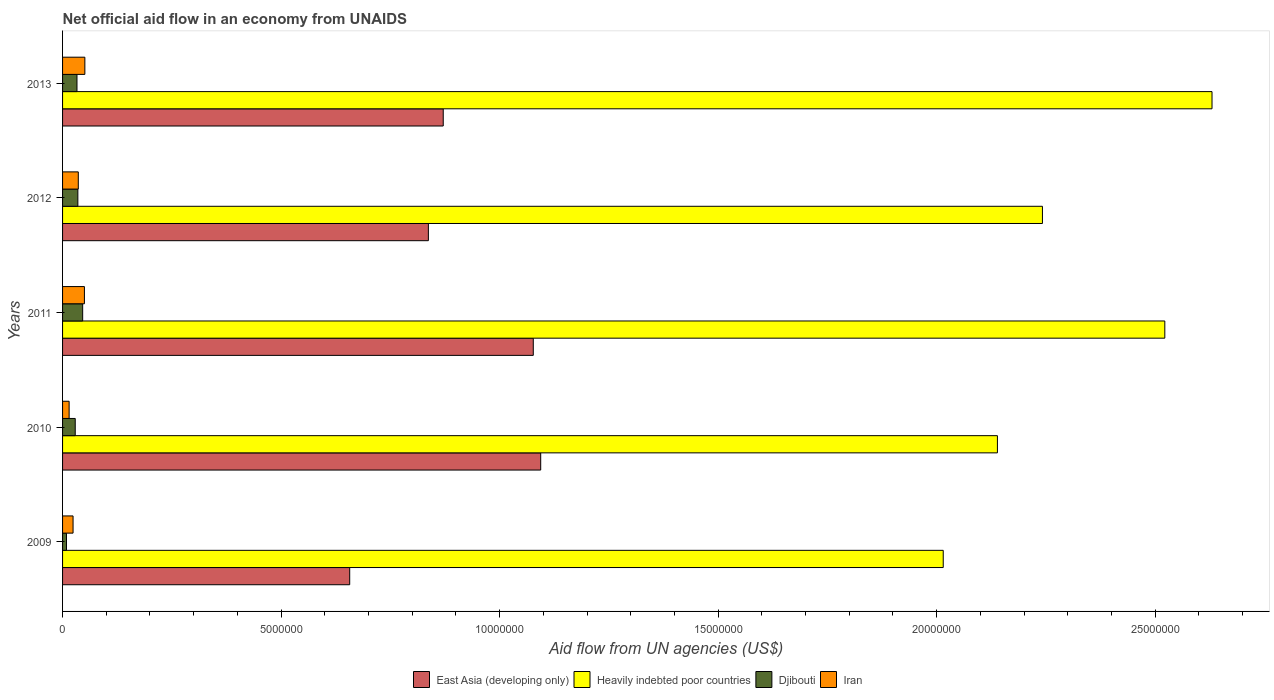How many different coloured bars are there?
Your answer should be compact. 4. Are the number of bars per tick equal to the number of legend labels?
Your response must be concise. Yes. Are the number of bars on each tick of the Y-axis equal?
Give a very brief answer. Yes. How many bars are there on the 3rd tick from the bottom?
Your answer should be very brief. 4. What is the label of the 5th group of bars from the top?
Make the answer very short. 2009. What is the net official aid flow in Heavily indebted poor countries in 2013?
Ensure brevity in your answer.  2.63e+07. Across all years, what is the maximum net official aid flow in Iran?
Your response must be concise. 5.10e+05. Across all years, what is the minimum net official aid flow in Djibouti?
Provide a short and direct response. 9.00e+04. In which year was the net official aid flow in Djibouti maximum?
Keep it short and to the point. 2011. What is the total net official aid flow in East Asia (developing only) in the graph?
Give a very brief answer. 4.54e+07. What is the difference between the net official aid flow in Heavily indebted poor countries in 2010 and the net official aid flow in Djibouti in 2012?
Your answer should be very brief. 2.10e+07. What is the average net official aid flow in East Asia (developing only) per year?
Ensure brevity in your answer.  9.07e+06. In the year 2011, what is the difference between the net official aid flow in Djibouti and net official aid flow in Iran?
Keep it short and to the point. -4.00e+04. In how many years, is the net official aid flow in East Asia (developing only) greater than 13000000 US$?
Provide a succinct answer. 0. What is the ratio of the net official aid flow in East Asia (developing only) in 2012 to that in 2013?
Your response must be concise. 0.96. Is the net official aid flow in Heavily indebted poor countries in 2009 less than that in 2010?
Give a very brief answer. Yes. Is the difference between the net official aid flow in Djibouti in 2010 and 2013 greater than the difference between the net official aid flow in Iran in 2010 and 2013?
Provide a short and direct response. Yes. What is the difference between the highest and the second highest net official aid flow in Heavily indebted poor countries?
Offer a terse response. 1.08e+06. What does the 3rd bar from the top in 2010 represents?
Your answer should be compact. Heavily indebted poor countries. What does the 4th bar from the bottom in 2012 represents?
Your response must be concise. Iran. Is it the case that in every year, the sum of the net official aid flow in Heavily indebted poor countries and net official aid flow in East Asia (developing only) is greater than the net official aid flow in Djibouti?
Your answer should be compact. Yes. How many bars are there?
Give a very brief answer. 20. What is the difference between two consecutive major ticks on the X-axis?
Ensure brevity in your answer.  5.00e+06. How many legend labels are there?
Your answer should be compact. 4. What is the title of the graph?
Provide a short and direct response. Net official aid flow in an economy from UNAIDS. What is the label or title of the X-axis?
Keep it short and to the point. Aid flow from UN agencies (US$). What is the Aid flow from UN agencies (US$) of East Asia (developing only) in 2009?
Ensure brevity in your answer.  6.57e+06. What is the Aid flow from UN agencies (US$) in Heavily indebted poor countries in 2009?
Ensure brevity in your answer.  2.02e+07. What is the Aid flow from UN agencies (US$) in Djibouti in 2009?
Ensure brevity in your answer.  9.00e+04. What is the Aid flow from UN agencies (US$) of East Asia (developing only) in 2010?
Your answer should be compact. 1.09e+07. What is the Aid flow from UN agencies (US$) in Heavily indebted poor countries in 2010?
Your response must be concise. 2.14e+07. What is the Aid flow from UN agencies (US$) in East Asia (developing only) in 2011?
Your answer should be compact. 1.08e+07. What is the Aid flow from UN agencies (US$) of Heavily indebted poor countries in 2011?
Provide a succinct answer. 2.52e+07. What is the Aid flow from UN agencies (US$) of Iran in 2011?
Ensure brevity in your answer.  5.00e+05. What is the Aid flow from UN agencies (US$) of East Asia (developing only) in 2012?
Give a very brief answer. 8.37e+06. What is the Aid flow from UN agencies (US$) of Heavily indebted poor countries in 2012?
Ensure brevity in your answer.  2.24e+07. What is the Aid flow from UN agencies (US$) in Djibouti in 2012?
Provide a succinct answer. 3.50e+05. What is the Aid flow from UN agencies (US$) in East Asia (developing only) in 2013?
Keep it short and to the point. 8.71e+06. What is the Aid flow from UN agencies (US$) in Heavily indebted poor countries in 2013?
Your answer should be very brief. 2.63e+07. What is the Aid flow from UN agencies (US$) of Djibouti in 2013?
Give a very brief answer. 3.30e+05. What is the Aid flow from UN agencies (US$) of Iran in 2013?
Offer a terse response. 5.10e+05. Across all years, what is the maximum Aid flow from UN agencies (US$) in East Asia (developing only)?
Offer a terse response. 1.09e+07. Across all years, what is the maximum Aid flow from UN agencies (US$) of Heavily indebted poor countries?
Give a very brief answer. 2.63e+07. Across all years, what is the maximum Aid flow from UN agencies (US$) of Iran?
Make the answer very short. 5.10e+05. Across all years, what is the minimum Aid flow from UN agencies (US$) in East Asia (developing only)?
Offer a terse response. 6.57e+06. Across all years, what is the minimum Aid flow from UN agencies (US$) in Heavily indebted poor countries?
Offer a very short reply. 2.02e+07. Across all years, what is the minimum Aid flow from UN agencies (US$) of Iran?
Provide a succinct answer. 1.50e+05. What is the total Aid flow from UN agencies (US$) in East Asia (developing only) in the graph?
Ensure brevity in your answer.  4.54e+07. What is the total Aid flow from UN agencies (US$) of Heavily indebted poor countries in the graph?
Offer a terse response. 1.15e+08. What is the total Aid flow from UN agencies (US$) of Djibouti in the graph?
Your answer should be compact. 1.52e+06. What is the total Aid flow from UN agencies (US$) in Iran in the graph?
Offer a terse response. 1.76e+06. What is the difference between the Aid flow from UN agencies (US$) in East Asia (developing only) in 2009 and that in 2010?
Your response must be concise. -4.37e+06. What is the difference between the Aid flow from UN agencies (US$) of Heavily indebted poor countries in 2009 and that in 2010?
Give a very brief answer. -1.24e+06. What is the difference between the Aid flow from UN agencies (US$) in Iran in 2009 and that in 2010?
Make the answer very short. 9.00e+04. What is the difference between the Aid flow from UN agencies (US$) of East Asia (developing only) in 2009 and that in 2011?
Offer a very short reply. -4.20e+06. What is the difference between the Aid flow from UN agencies (US$) in Heavily indebted poor countries in 2009 and that in 2011?
Your response must be concise. -5.07e+06. What is the difference between the Aid flow from UN agencies (US$) in Djibouti in 2009 and that in 2011?
Offer a terse response. -3.70e+05. What is the difference between the Aid flow from UN agencies (US$) in East Asia (developing only) in 2009 and that in 2012?
Provide a succinct answer. -1.80e+06. What is the difference between the Aid flow from UN agencies (US$) of Heavily indebted poor countries in 2009 and that in 2012?
Provide a short and direct response. -2.27e+06. What is the difference between the Aid flow from UN agencies (US$) in East Asia (developing only) in 2009 and that in 2013?
Your response must be concise. -2.14e+06. What is the difference between the Aid flow from UN agencies (US$) of Heavily indebted poor countries in 2009 and that in 2013?
Offer a terse response. -6.15e+06. What is the difference between the Aid flow from UN agencies (US$) of Djibouti in 2009 and that in 2013?
Offer a very short reply. -2.40e+05. What is the difference between the Aid flow from UN agencies (US$) of Heavily indebted poor countries in 2010 and that in 2011?
Keep it short and to the point. -3.83e+06. What is the difference between the Aid flow from UN agencies (US$) of Iran in 2010 and that in 2011?
Give a very brief answer. -3.50e+05. What is the difference between the Aid flow from UN agencies (US$) in East Asia (developing only) in 2010 and that in 2012?
Keep it short and to the point. 2.57e+06. What is the difference between the Aid flow from UN agencies (US$) in Heavily indebted poor countries in 2010 and that in 2012?
Provide a short and direct response. -1.03e+06. What is the difference between the Aid flow from UN agencies (US$) in Iran in 2010 and that in 2012?
Your answer should be very brief. -2.10e+05. What is the difference between the Aid flow from UN agencies (US$) of East Asia (developing only) in 2010 and that in 2013?
Offer a terse response. 2.23e+06. What is the difference between the Aid flow from UN agencies (US$) in Heavily indebted poor countries in 2010 and that in 2013?
Give a very brief answer. -4.91e+06. What is the difference between the Aid flow from UN agencies (US$) in Iran in 2010 and that in 2013?
Offer a very short reply. -3.60e+05. What is the difference between the Aid flow from UN agencies (US$) in East Asia (developing only) in 2011 and that in 2012?
Your answer should be compact. 2.40e+06. What is the difference between the Aid flow from UN agencies (US$) of Heavily indebted poor countries in 2011 and that in 2012?
Provide a short and direct response. 2.80e+06. What is the difference between the Aid flow from UN agencies (US$) of Djibouti in 2011 and that in 2012?
Give a very brief answer. 1.10e+05. What is the difference between the Aid flow from UN agencies (US$) of Iran in 2011 and that in 2012?
Ensure brevity in your answer.  1.40e+05. What is the difference between the Aid flow from UN agencies (US$) of East Asia (developing only) in 2011 and that in 2013?
Your response must be concise. 2.06e+06. What is the difference between the Aid flow from UN agencies (US$) of Heavily indebted poor countries in 2011 and that in 2013?
Make the answer very short. -1.08e+06. What is the difference between the Aid flow from UN agencies (US$) in Heavily indebted poor countries in 2012 and that in 2013?
Offer a very short reply. -3.88e+06. What is the difference between the Aid flow from UN agencies (US$) of East Asia (developing only) in 2009 and the Aid flow from UN agencies (US$) of Heavily indebted poor countries in 2010?
Your response must be concise. -1.48e+07. What is the difference between the Aid flow from UN agencies (US$) in East Asia (developing only) in 2009 and the Aid flow from UN agencies (US$) in Djibouti in 2010?
Give a very brief answer. 6.28e+06. What is the difference between the Aid flow from UN agencies (US$) of East Asia (developing only) in 2009 and the Aid flow from UN agencies (US$) of Iran in 2010?
Your answer should be very brief. 6.42e+06. What is the difference between the Aid flow from UN agencies (US$) of Heavily indebted poor countries in 2009 and the Aid flow from UN agencies (US$) of Djibouti in 2010?
Make the answer very short. 1.99e+07. What is the difference between the Aid flow from UN agencies (US$) of Djibouti in 2009 and the Aid flow from UN agencies (US$) of Iran in 2010?
Your answer should be very brief. -6.00e+04. What is the difference between the Aid flow from UN agencies (US$) of East Asia (developing only) in 2009 and the Aid flow from UN agencies (US$) of Heavily indebted poor countries in 2011?
Give a very brief answer. -1.86e+07. What is the difference between the Aid flow from UN agencies (US$) of East Asia (developing only) in 2009 and the Aid flow from UN agencies (US$) of Djibouti in 2011?
Offer a terse response. 6.11e+06. What is the difference between the Aid flow from UN agencies (US$) of East Asia (developing only) in 2009 and the Aid flow from UN agencies (US$) of Iran in 2011?
Your answer should be very brief. 6.07e+06. What is the difference between the Aid flow from UN agencies (US$) of Heavily indebted poor countries in 2009 and the Aid flow from UN agencies (US$) of Djibouti in 2011?
Your answer should be very brief. 1.97e+07. What is the difference between the Aid flow from UN agencies (US$) in Heavily indebted poor countries in 2009 and the Aid flow from UN agencies (US$) in Iran in 2011?
Make the answer very short. 1.96e+07. What is the difference between the Aid flow from UN agencies (US$) in Djibouti in 2009 and the Aid flow from UN agencies (US$) in Iran in 2011?
Ensure brevity in your answer.  -4.10e+05. What is the difference between the Aid flow from UN agencies (US$) of East Asia (developing only) in 2009 and the Aid flow from UN agencies (US$) of Heavily indebted poor countries in 2012?
Give a very brief answer. -1.58e+07. What is the difference between the Aid flow from UN agencies (US$) in East Asia (developing only) in 2009 and the Aid flow from UN agencies (US$) in Djibouti in 2012?
Your answer should be compact. 6.22e+06. What is the difference between the Aid flow from UN agencies (US$) of East Asia (developing only) in 2009 and the Aid flow from UN agencies (US$) of Iran in 2012?
Keep it short and to the point. 6.21e+06. What is the difference between the Aid flow from UN agencies (US$) in Heavily indebted poor countries in 2009 and the Aid flow from UN agencies (US$) in Djibouti in 2012?
Your answer should be very brief. 1.98e+07. What is the difference between the Aid flow from UN agencies (US$) of Heavily indebted poor countries in 2009 and the Aid flow from UN agencies (US$) of Iran in 2012?
Provide a short and direct response. 1.98e+07. What is the difference between the Aid flow from UN agencies (US$) of East Asia (developing only) in 2009 and the Aid flow from UN agencies (US$) of Heavily indebted poor countries in 2013?
Keep it short and to the point. -1.97e+07. What is the difference between the Aid flow from UN agencies (US$) in East Asia (developing only) in 2009 and the Aid flow from UN agencies (US$) in Djibouti in 2013?
Provide a short and direct response. 6.24e+06. What is the difference between the Aid flow from UN agencies (US$) in East Asia (developing only) in 2009 and the Aid flow from UN agencies (US$) in Iran in 2013?
Provide a succinct answer. 6.06e+06. What is the difference between the Aid flow from UN agencies (US$) in Heavily indebted poor countries in 2009 and the Aid flow from UN agencies (US$) in Djibouti in 2013?
Give a very brief answer. 1.98e+07. What is the difference between the Aid flow from UN agencies (US$) of Heavily indebted poor countries in 2009 and the Aid flow from UN agencies (US$) of Iran in 2013?
Your response must be concise. 1.96e+07. What is the difference between the Aid flow from UN agencies (US$) of Djibouti in 2009 and the Aid flow from UN agencies (US$) of Iran in 2013?
Provide a short and direct response. -4.20e+05. What is the difference between the Aid flow from UN agencies (US$) in East Asia (developing only) in 2010 and the Aid flow from UN agencies (US$) in Heavily indebted poor countries in 2011?
Your answer should be very brief. -1.43e+07. What is the difference between the Aid flow from UN agencies (US$) in East Asia (developing only) in 2010 and the Aid flow from UN agencies (US$) in Djibouti in 2011?
Give a very brief answer. 1.05e+07. What is the difference between the Aid flow from UN agencies (US$) in East Asia (developing only) in 2010 and the Aid flow from UN agencies (US$) in Iran in 2011?
Offer a terse response. 1.04e+07. What is the difference between the Aid flow from UN agencies (US$) of Heavily indebted poor countries in 2010 and the Aid flow from UN agencies (US$) of Djibouti in 2011?
Provide a succinct answer. 2.09e+07. What is the difference between the Aid flow from UN agencies (US$) in Heavily indebted poor countries in 2010 and the Aid flow from UN agencies (US$) in Iran in 2011?
Keep it short and to the point. 2.09e+07. What is the difference between the Aid flow from UN agencies (US$) in Djibouti in 2010 and the Aid flow from UN agencies (US$) in Iran in 2011?
Your response must be concise. -2.10e+05. What is the difference between the Aid flow from UN agencies (US$) in East Asia (developing only) in 2010 and the Aid flow from UN agencies (US$) in Heavily indebted poor countries in 2012?
Your answer should be compact. -1.15e+07. What is the difference between the Aid flow from UN agencies (US$) of East Asia (developing only) in 2010 and the Aid flow from UN agencies (US$) of Djibouti in 2012?
Make the answer very short. 1.06e+07. What is the difference between the Aid flow from UN agencies (US$) of East Asia (developing only) in 2010 and the Aid flow from UN agencies (US$) of Iran in 2012?
Make the answer very short. 1.06e+07. What is the difference between the Aid flow from UN agencies (US$) in Heavily indebted poor countries in 2010 and the Aid flow from UN agencies (US$) in Djibouti in 2012?
Provide a succinct answer. 2.10e+07. What is the difference between the Aid flow from UN agencies (US$) of Heavily indebted poor countries in 2010 and the Aid flow from UN agencies (US$) of Iran in 2012?
Provide a short and direct response. 2.10e+07. What is the difference between the Aid flow from UN agencies (US$) of Djibouti in 2010 and the Aid flow from UN agencies (US$) of Iran in 2012?
Your response must be concise. -7.00e+04. What is the difference between the Aid flow from UN agencies (US$) of East Asia (developing only) in 2010 and the Aid flow from UN agencies (US$) of Heavily indebted poor countries in 2013?
Your answer should be compact. -1.54e+07. What is the difference between the Aid flow from UN agencies (US$) in East Asia (developing only) in 2010 and the Aid flow from UN agencies (US$) in Djibouti in 2013?
Offer a very short reply. 1.06e+07. What is the difference between the Aid flow from UN agencies (US$) of East Asia (developing only) in 2010 and the Aid flow from UN agencies (US$) of Iran in 2013?
Offer a very short reply. 1.04e+07. What is the difference between the Aid flow from UN agencies (US$) in Heavily indebted poor countries in 2010 and the Aid flow from UN agencies (US$) in Djibouti in 2013?
Offer a very short reply. 2.11e+07. What is the difference between the Aid flow from UN agencies (US$) of Heavily indebted poor countries in 2010 and the Aid flow from UN agencies (US$) of Iran in 2013?
Your answer should be very brief. 2.09e+07. What is the difference between the Aid flow from UN agencies (US$) in East Asia (developing only) in 2011 and the Aid flow from UN agencies (US$) in Heavily indebted poor countries in 2012?
Offer a terse response. -1.16e+07. What is the difference between the Aid flow from UN agencies (US$) in East Asia (developing only) in 2011 and the Aid flow from UN agencies (US$) in Djibouti in 2012?
Offer a terse response. 1.04e+07. What is the difference between the Aid flow from UN agencies (US$) of East Asia (developing only) in 2011 and the Aid flow from UN agencies (US$) of Iran in 2012?
Your answer should be compact. 1.04e+07. What is the difference between the Aid flow from UN agencies (US$) in Heavily indebted poor countries in 2011 and the Aid flow from UN agencies (US$) in Djibouti in 2012?
Your answer should be compact. 2.49e+07. What is the difference between the Aid flow from UN agencies (US$) in Heavily indebted poor countries in 2011 and the Aid flow from UN agencies (US$) in Iran in 2012?
Ensure brevity in your answer.  2.49e+07. What is the difference between the Aid flow from UN agencies (US$) of Djibouti in 2011 and the Aid flow from UN agencies (US$) of Iran in 2012?
Your response must be concise. 1.00e+05. What is the difference between the Aid flow from UN agencies (US$) of East Asia (developing only) in 2011 and the Aid flow from UN agencies (US$) of Heavily indebted poor countries in 2013?
Make the answer very short. -1.55e+07. What is the difference between the Aid flow from UN agencies (US$) of East Asia (developing only) in 2011 and the Aid flow from UN agencies (US$) of Djibouti in 2013?
Make the answer very short. 1.04e+07. What is the difference between the Aid flow from UN agencies (US$) of East Asia (developing only) in 2011 and the Aid flow from UN agencies (US$) of Iran in 2013?
Your answer should be compact. 1.03e+07. What is the difference between the Aid flow from UN agencies (US$) of Heavily indebted poor countries in 2011 and the Aid flow from UN agencies (US$) of Djibouti in 2013?
Your answer should be compact. 2.49e+07. What is the difference between the Aid flow from UN agencies (US$) in Heavily indebted poor countries in 2011 and the Aid flow from UN agencies (US$) in Iran in 2013?
Your response must be concise. 2.47e+07. What is the difference between the Aid flow from UN agencies (US$) in Djibouti in 2011 and the Aid flow from UN agencies (US$) in Iran in 2013?
Your answer should be very brief. -5.00e+04. What is the difference between the Aid flow from UN agencies (US$) in East Asia (developing only) in 2012 and the Aid flow from UN agencies (US$) in Heavily indebted poor countries in 2013?
Your response must be concise. -1.79e+07. What is the difference between the Aid flow from UN agencies (US$) of East Asia (developing only) in 2012 and the Aid flow from UN agencies (US$) of Djibouti in 2013?
Offer a terse response. 8.04e+06. What is the difference between the Aid flow from UN agencies (US$) of East Asia (developing only) in 2012 and the Aid flow from UN agencies (US$) of Iran in 2013?
Give a very brief answer. 7.86e+06. What is the difference between the Aid flow from UN agencies (US$) of Heavily indebted poor countries in 2012 and the Aid flow from UN agencies (US$) of Djibouti in 2013?
Give a very brief answer. 2.21e+07. What is the difference between the Aid flow from UN agencies (US$) of Heavily indebted poor countries in 2012 and the Aid flow from UN agencies (US$) of Iran in 2013?
Ensure brevity in your answer.  2.19e+07. What is the difference between the Aid flow from UN agencies (US$) in Djibouti in 2012 and the Aid flow from UN agencies (US$) in Iran in 2013?
Your answer should be very brief. -1.60e+05. What is the average Aid flow from UN agencies (US$) in East Asia (developing only) per year?
Ensure brevity in your answer.  9.07e+06. What is the average Aid flow from UN agencies (US$) of Heavily indebted poor countries per year?
Give a very brief answer. 2.31e+07. What is the average Aid flow from UN agencies (US$) in Djibouti per year?
Provide a short and direct response. 3.04e+05. What is the average Aid flow from UN agencies (US$) in Iran per year?
Make the answer very short. 3.52e+05. In the year 2009, what is the difference between the Aid flow from UN agencies (US$) of East Asia (developing only) and Aid flow from UN agencies (US$) of Heavily indebted poor countries?
Make the answer very short. -1.36e+07. In the year 2009, what is the difference between the Aid flow from UN agencies (US$) of East Asia (developing only) and Aid flow from UN agencies (US$) of Djibouti?
Give a very brief answer. 6.48e+06. In the year 2009, what is the difference between the Aid flow from UN agencies (US$) in East Asia (developing only) and Aid flow from UN agencies (US$) in Iran?
Give a very brief answer. 6.33e+06. In the year 2009, what is the difference between the Aid flow from UN agencies (US$) of Heavily indebted poor countries and Aid flow from UN agencies (US$) of Djibouti?
Your answer should be compact. 2.01e+07. In the year 2009, what is the difference between the Aid flow from UN agencies (US$) of Heavily indebted poor countries and Aid flow from UN agencies (US$) of Iran?
Ensure brevity in your answer.  1.99e+07. In the year 2009, what is the difference between the Aid flow from UN agencies (US$) of Djibouti and Aid flow from UN agencies (US$) of Iran?
Keep it short and to the point. -1.50e+05. In the year 2010, what is the difference between the Aid flow from UN agencies (US$) in East Asia (developing only) and Aid flow from UN agencies (US$) in Heavily indebted poor countries?
Your answer should be very brief. -1.04e+07. In the year 2010, what is the difference between the Aid flow from UN agencies (US$) of East Asia (developing only) and Aid flow from UN agencies (US$) of Djibouti?
Provide a succinct answer. 1.06e+07. In the year 2010, what is the difference between the Aid flow from UN agencies (US$) in East Asia (developing only) and Aid flow from UN agencies (US$) in Iran?
Keep it short and to the point. 1.08e+07. In the year 2010, what is the difference between the Aid flow from UN agencies (US$) in Heavily indebted poor countries and Aid flow from UN agencies (US$) in Djibouti?
Offer a very short reply. 2.11e+07. In the year 2010, what is the difference between the Aid flow from UN agencies (US$) in Heavily indebted poor countries and Aid flow from UN agencies (US$) in Iran?
Give a very brief answer. 2.12e+07. In the year 2010, what is the difference between the Aid flow from UN agencies (US$) in Djibouti and Aid flow from UN agencies (US$) in Iran?
Make the answer very short. 1.40e+05. In the year 2011, what is the difference between the Aid flow from UN agencies (US$) of East Asia (developing only) and Aid flow from UN agencies (US$) of Heavily indebted poor countries?
Offer a very short reply. -1.44e+07. In the year 2011, what is the difference between the Aid flow from UN agencies (US$) in East Asia (developing only) and Aid flow from UN agencies (US$) in Djibouti?
Your response must be concise. 1.03e+07. In the year 2011, what is the difference between the Aid flow from UN agencies (US$) of East Asia (developing only) and Aid flow from UN agencies (US$) of Iran?
Provide a succinct answer. 1.03e+07. In the year 2011, what is the difference between the Aid flow from UN agencies (US$) of Heavily indebted poor countries and Aid flow from UN agencies (US$) of Djibouti?
Provide a short and direct response. 2.48e+07. In the year 2011, what is the difference between the Aid flow from UN agencies (US$) of Heavily indebted poor countries and Aid flow from UN agencies (US$) of Iran?
Your answer should be compact. 2.47e+07. In the year 2011, what is the difference between the Aid flow from UN agencies (US$) in Djibouti and Aid flow from UN agencies (US$) in Iran?
Offer a very short reply. -4.00e+04. In the year 2012, what is the difference between the Aid flow from UN agencies (US$) of East Asia (developing only) and Aid flow from UN agencies (US$) of Heavily indebted poor countries?
Your answer should be compact. -1.40e+07. In the year 2012, what is the difference between the Aid flow from UN agencies (US$) in East Asia (developing only) and Aid flow from UN agencies (US$) in Djibouti?
Provide a succinct answer. 8.02e+06. In the year 2012, what is the difference between the Aid flow from UN agencies (US$) in East Asia (developing only) and Aid flow from UN agencies (US$) in Iran?
Provide a succinct answer. 8.01e+06. In the year 2012, what is the difference between the Aid flow from UN agencies (US$) in Heavily indebted poor countries and Aid flow from UN agencies (US$) in Djibouti?
Give a very brief answer. 2.21e+07. In the year 2012, what is the difference between the Aid flow from UN agencies (US$) in Heavily indebted poor countries and Aid flow from UN agencies (US$) in Iran?
Your answer should be very brief. 2.21e+07. In the year 2012, what is the difference between the Aid flow from UN agencies (US$) of Djibouti and Aid flow from UN agencies (US$) of Iran?
Your answer should be compact. -10000. In the year 2013, what is the difference between the Aid flow from UN agencies (US$) of East Asia (developing only) and Aid flow from UN agencies (US$) of Heavily indebted poor countries?
Provide a short and direct response. -1.76e+07. In the year 2013, what is the difference between the Aid flow from UN agencies (US$) of East Asia (developing only) and Aid flow from UN agencies (US$) of Djibouti?
Offer a terse response. 8.38e+06. In the year 2013, what is the difference between the Aid flow from UN agencies (US$) of East Asia (developing only) and Aid flow from UN agencies (US$) of Iran?
Offer a very short reply. 8.20e+06. In the year 2013, what is the difference between the Aid flow from UN agencies (US$) of Heavily indebted poor countries and Aid flow from UN agencies (US$) of Djibouti?
Provide a short and direct response. 2.60e+07. In the year 2013, what is the difference between the Aid flow from UN agencies (US$) of Heavily indebted poor countries and Aid flow from UN agencies (US$) of Iran?
Offer a terse response. 2.58e+07. What is the ratio of the Aid flow from UN agencies (US$) of East Asia (developing only) in 2009 to that in 2010?
Your response must be concise. 0.6. What is the ratio of the Aid flow from UN agencies (US$) in Heavily indebted poor countries in 2009 to that in 2010?
Make the answer very short. 0.94. What is the ratio of the Aid flow from UN agencies (US$) in Djibouti in 2009 to that in 2010?
Offer a terse response. 0.31. What is the ratio of the Aid flow from UN agencies (US$) in Iran in 2009 to that in 2010?
Make the answer very short. 1.6. What is the ratio of the Aid flow from UN agencies (US$) in East Asia (developing only) in 2009 to that in 2011?
Provide a short and direct response. 0.61. What is the ratio of the Aid flow from UN agencies (US$) of Heavily indebted poor countries in 2009 to that in 2011?
Provide a short and direct response. 0.8. What is the ratio of the Aid flow from UN agencies (US$) of Djibouti in 2009 to that in 2011?
Ensure brevity in your answer.  0.2. What is the ratio of the Aid flow from UN agencies (US$) in Iran in 2009 to that in 2011?
Offer a very short reply. 0.48. What is the ratio of the Aid flow from UN agencies (US$) in East Asia (developing only) in 2009 to that in 2012?
Provide a succinct answer. 0.78. What is the ratio of the Aid flow from UN agencies (US$) of Heavily indebted poor countries in 2009 to that in 2012?
Your answer should be compact. 0.9. What is the ratio of the Aid flow from UN agencies (US$) of Djibouti in 2009 to that in 2012?
Provide a short and direct response. 0.26. What is the ratio of the Aid flow from UN agencies (US$) of East Asia (developing only) in 2009 to that in 2013?
Provide a succinct answer. 0.75. What is the ratio of the Aid flow from UN agencies (US$) in Heavily indebted poor countries in 2009 to that in 2013?
Offer a terse response. 0.77. What is the ratio of the Aid flow from UN agencies (US$) of Djibouti in 2009 to that in 2013?
Ensure brevity in your answer.  0.27. What is the ratio of the Aid flow from UN agencies (US$) in Iran in 2009 to that in 2013?
Offer a terse response. 0.47. What is the ratio of the Aid flow from UN agencies (US$) in East Asia (developing only) in 2010 to that in 2011?
Provide a succinct answer. 1.02. What is the ratio of the Aid flow from UN agencies (US$) of Heavily indebted poor countries in 2010 to that in 2011?
Make the answer very short. 0.85. What is the ratio of the Aid flow from UN agencies (US$) in Djibouti in 2010 to that in 2011?
Provide a short and direct response. 0.63. What is the ratio of the Aid flow from UN agencies (US$) in Iran in 2010 to that in 2011?
Provide a succinct answer. 0.3. What is the ratio of the Aid flow from UN agencies (US$) in East Asia (developing only) in 2010 to that in 2012?
Offer a terse response. 1.31. What is the ratio of the Aid flow from UN agencies (US$) of Heavily indebted poor countries in 2010 to that in 2012?
Your answer should be very brief. 0.95. What is the ratio of the Aid flow from UN agencies (US$) of Djibouti in 2010 to that in 2012?
Ensure brevity in your answer.  0.83. What is the ratio of the Aid flow from UN agencies (US$) in Iran in 2010 to that in 2012?
Make the answer very short. 0.42. What is the ratio of the Aid flow from UN agencies (US$) in East Asia (developing only) in 2010 to that in 2013?
Your answer should be compact. 1.26. What is the ratio of the Aid flow from UN agencies (US$) of Heavily indebted poor countries in 2010 to that in 2013?
Your answer should be compact. 0.81. What is the ratio of the Aid flow from UN agencies (US$) in Djibouti in 2010 to that in 2013?
Your response must be concise. 0.88. What is the ratio of the Aid flow from UN agencies (US$) of Iran in 2010 to that in 2013?
Provide a short and direct response. 0.29. What is the ratio of the Aid flow from UN agencies (US$) of East Asia (developing only) in 2011 to that in 2012?
Your answer should be very brief. 1.29. What is the ratio of the Aid flow from UN agencies (US$) of Heavily indebted poor countries in 2011 to that in 2012?
Make the answer very short. 1.12. What is the ratio of the Aid flow from UN agencies (US$) in Djibouti in 2011 to that in 2012?
Keep it short and to the point. 1.31. What is the ratio of the Aid flow from UN agencies (US$) of Iran in 2011 to that in 2012?
Your answer should be compact. 1.39. What is the ratio of the Aid flow from UN agencies (US$) in East Asia (developing only) in 2011 to that in 2013?
Provide a short and direct response. 1.24. What is the ratio of the Aid flow from UN agencies (US$) of Heavily indebted poor countries in 2011 to that in 2013?
Keep it short and to the point. 0.96. What is the ratio of the Aid flow from UN agencies (US$) in Djibouti in 2011 to that in 2013?
Ensure brevity in your answer.  1.39. What is the ratio of the Aid flow from UN agencies (US$) in Iran in 2011 to that in 2013?
Offer a terse response. 0.98. What is the ratio of the Aid flow from UN agencies (US$) in Heavily indebted poor countries in 2012 to that in 2013?
Your answer should be compact. 0.85. What is the ratio of the Aid flow from UN agencies (US$) of Djibouti in 2012 to that in 2013?
Offer a very short reply. 1.06. What is the ratio of the Aid flow from UN agencies (US$) of Iran in 2012 to that in 2013?
Keep it short and to the point. 0.71. What is the difference between the highest and the second highest Aid flow from UN agencies (US$) in East Asia (developing only)?
Keep it short and to the point. 1.70e+05. What is the difference between the highest and the second highest Aid flow from UN agencies (US$) of Heavily indebted poor countries?
Offer a terse response. 1.08e+06. What is the difference between the highest and the second highest Aid flow from UN agencies (US$) of Djibouti?
Offer a very short reply. 1.10e+05. What is the difference between the highest and the second highest Aid flow from UN agencies (US$) of Iran?
Your answer should be compact. 10000. What is the difference between the highest and the lowest Aid flow from UN agencies (US$) of East Asia (developing only)?
Provide a short and direct response. 4.37e+06. What is the difference between the highest and the lowest Aid flow from UN agencies (US$) of Heavily indebted poor countries?
Ensure brevity in your answer.  6.15e+06. What is the difference between the highest and the lowest Aid flow from UN agencies (US$) of Djibouti?
Your answer should be very brief. 3.70e+05. What is the difference between the highest and the lowest Aid flow from UN agencies (US$) of Iran?
Give a very brief answer. 3.60e+05. 